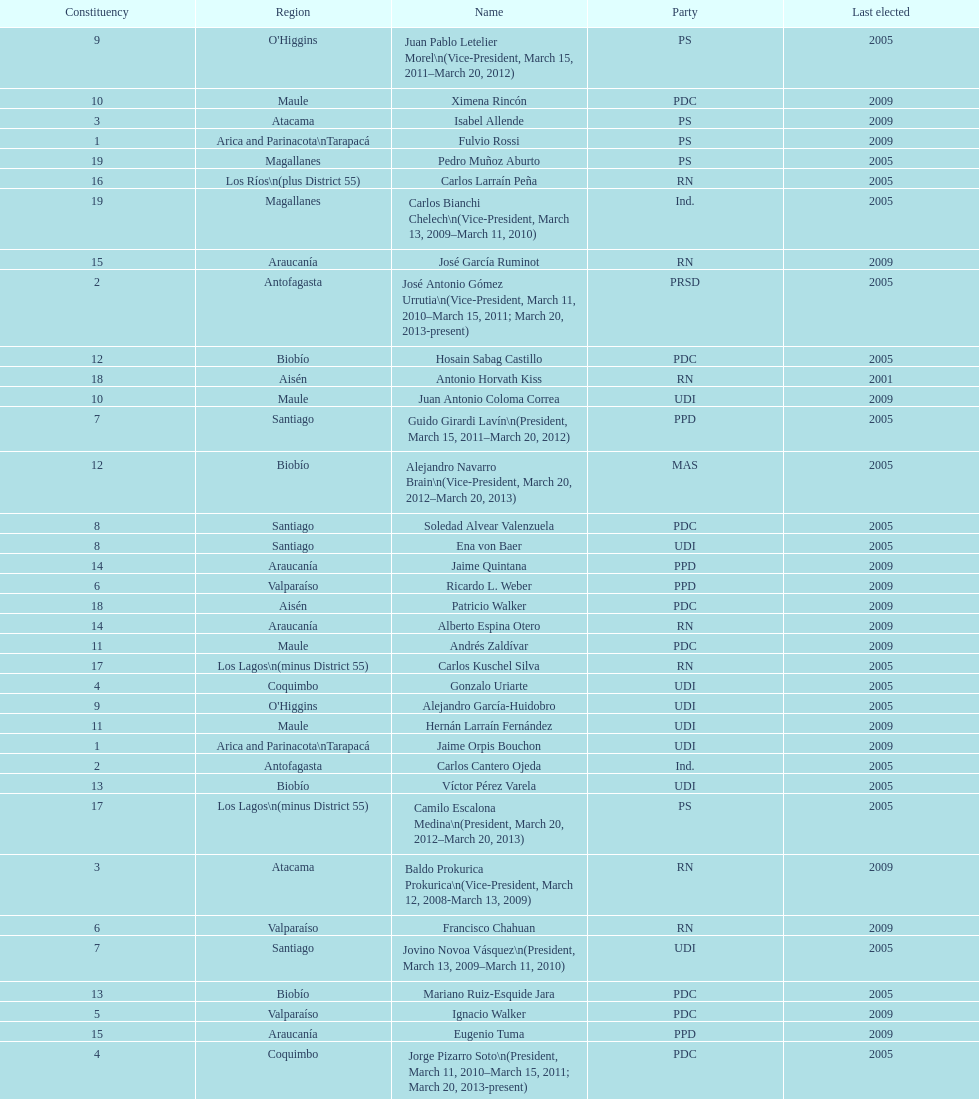What is the last region listed on the table? Magallanes. 